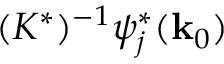<formula> <loc_0><loc_0><loc_500><loc_500>( K ^ { * } ) ^ { - 1 } \psi _ { j } ^ { * } ( { k } _ { 0 } )</formula> 